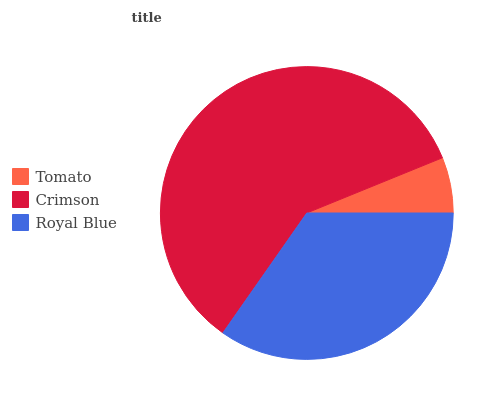Is Tomato the minimum?
Answer yes or no. Yes. Is Crimson the maximum?
Answer yes or no. Yes. Is Royal Blue the minimum?
Answer yes or no. No. Is Royal Blue the maximum?
Answer yes or no. No. Is Crimson greater than Royal Blue?
Answer yes or no. Yes. Is Royal Blue less than Crimson?
Answer yes or no. Yes. Is Royal Blue greater than Crimson?
Answer yes or no. No. Is Crimson less than Royal Blue?
Answer yes or no. No. Is Royal Blue the high median?
Answer yes or no. Yes. Is Royal Blue the low median?
Answer yes or no. Yes. Is Crimson the high median?
Answer yes or no. No. Is Tomato the low median?
Answer yes or no. No. 